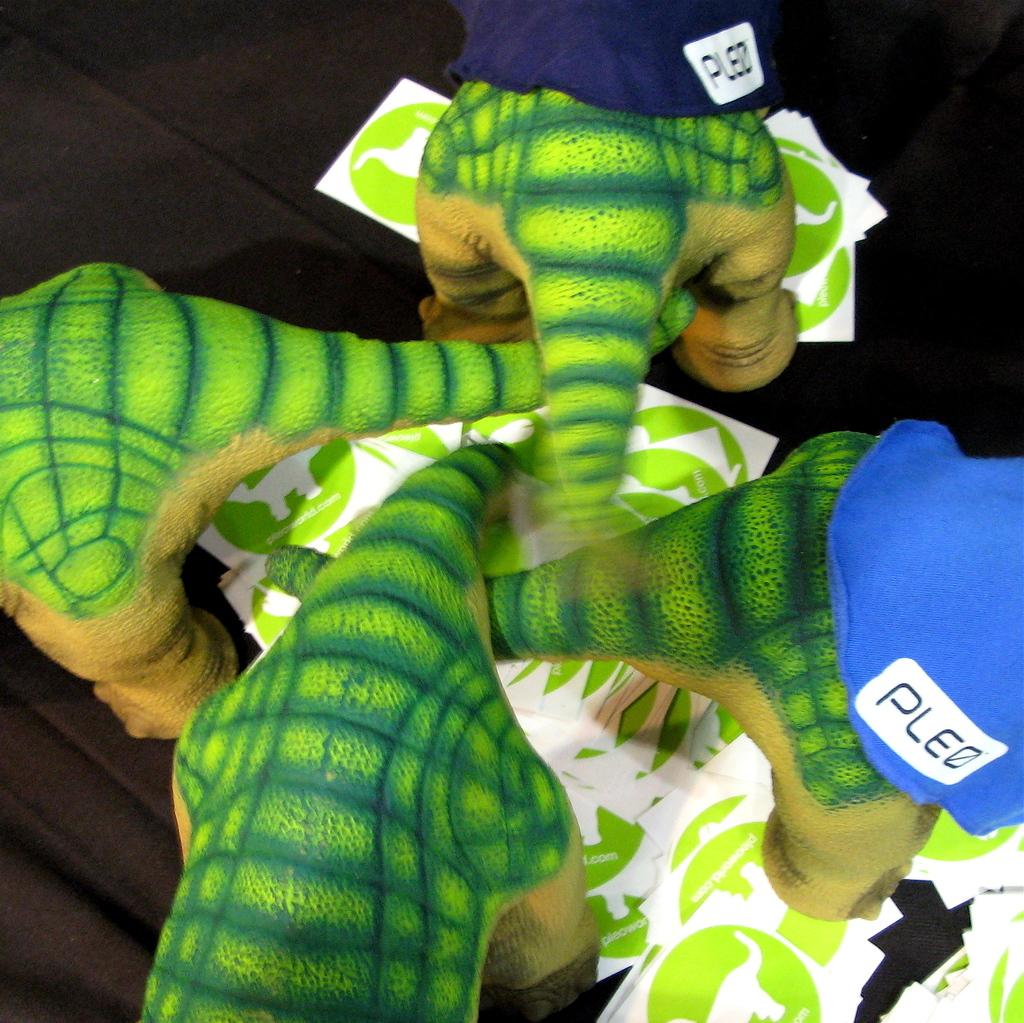How many toys can be seen in the image? There are four toys in the image. What other items are present in the image besides the toys? There are papers and clothes in the image. Where are these items located in the image? These items are placed on a platform. What type of stamp can be seen on the clothes in the image? There is no stamp visible on the clothes in the image. 